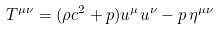<formula> <loc_0><loc_0><loc_500><loc_500>T ^ { \mu \nu } = ( \rho c ^ { 2 } + p ) u ^ { \mu } u ^ { \nu } - p \, \eta ^ { \mu \nu }</formula> 